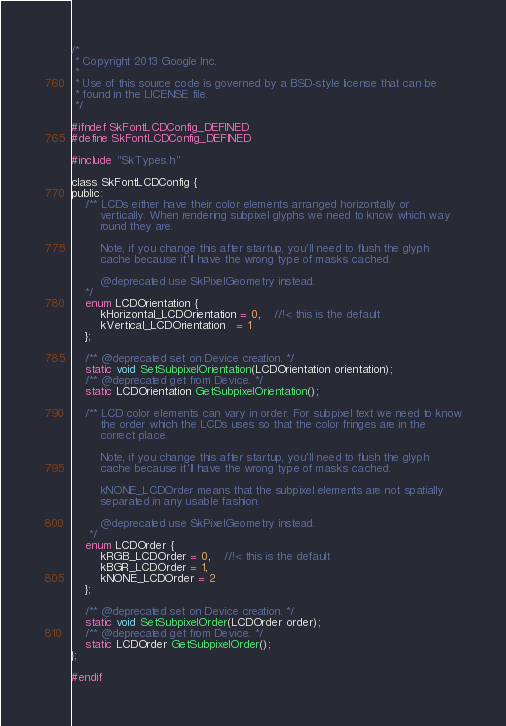<code> <loc_0><loc_0><loc_500><loc_500><_C_>/*
 * Copyright 2013 Google Inc.
 *
 * Use of this source code is governed by a BSD-style license that can be
 * found in the LICENSE file.
 */

#ifndef SkFontLCDConfig_DEFINED
#define SkFontLCDConfig_DEFINED

#include "SkTypes.h"

class SkFontLCDConfig {
public:
    /** LCDs either have their color elements arranged horizontally or
        vertically. When rendering subpixel glyphs we need to know which way
        round they are.

        Note, if you change this after startup, you'll need to flush the glyph
        cache because it'll have the wrong type of masks cached.

        @deprecated use SkPixelGeometry instead.
    */
    enum LCDOrientation {
        kHorizontal_LCDOrientation = 0,    //!< this is the default
        kVertical_LCDOrientation   = 1
    };

    /** @deprecated set on Device creation. */
    static void SetSubpixelOrientation(LCDOrientation orientation);
    /** @deprecated get from Device. */
    static LCDOrientation GetSubpixelOrientation();

    /** LCD color elements can vary in order. For subpixel text we need to know
        the order which the LCDs uses so that the color fringes are in the
        correct place.

        Note, if you change this after startup, you'll need to flush the glyph
        cache because it'll have the wrong type of masks cached.

        kNONE_LCDOrder means that the subpixel elements are not spatially
        separated in any usable fashion.

        @deprecated use SkPixelGeometry instead.
     */
    enum LCDOrder {
        kRGB_LCDOrder = 0,    //!< this is the default
        kBGR_LCDOrder = 1,
        kNONE_LCDOrder = 2
    };

    /** @deprecated set on Device creation. */
    static void SetSubpixelOrder(LCDOrder order);
    /** @deprecated get from Device. */
    static LCDOrder GetSubpixelOrder();
};

#endif
</code> 